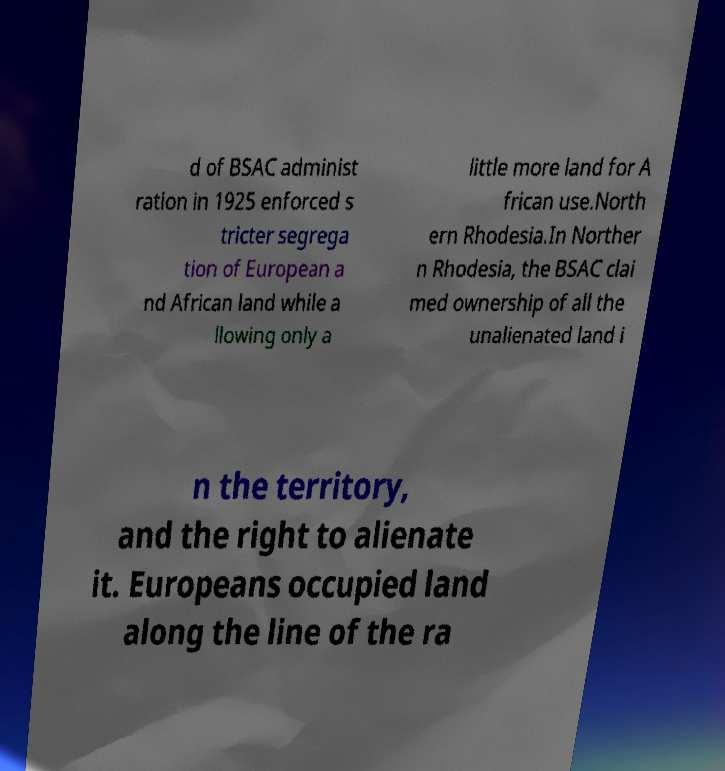Could you assist in decoding the text presented in this image and type it out clearly? d of BSAC administ ration in 1925 enforced s tricter segrega tion of European a nd African land while a llowing only a little more land for A frican use.North ern Rhodesia.In Norther n Rhodesia, the BSAC clai med ownership of all the unalienated land i n the territory, and the right to alienate it. Europeans occupied land along the line of the ra 